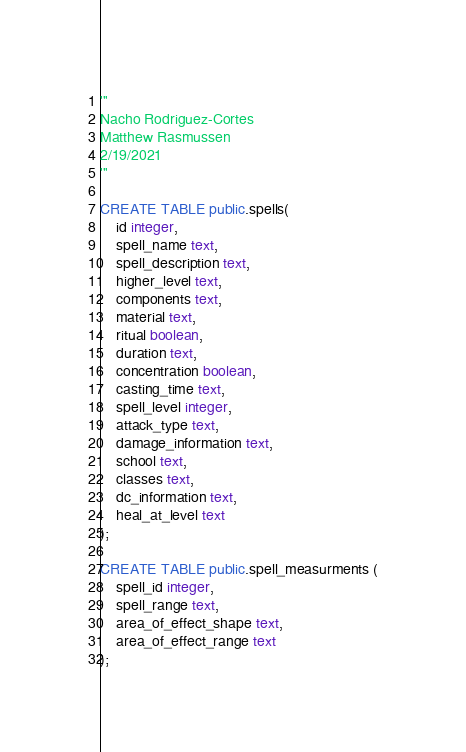<code> <loc_0><loc_0><loc_500><loc_500><_SQL_>'''
Nacho Rodriguez-Cortes
Matthew Rasmussen
2/19/2021
'''

CREATE TABLE public.spells(
    id integer,
    spell_name text,
    spell_description text,
    higher_level text,
    components text,
    material text,
    ritual boolean,
    duration text,
    concentration boolean,
    casting_time text,
    spell_level integer,
    attack_type text,
    damage_information text,
    school text,
    classes text,
    dc_information text,
    heal_at_level text
);

CREATE TABLE public.spell_measurments (
    spell_id integer,
    spell_range text,
    area_of_effect_shape text,
    area_of_effect_range text
);
</code> 